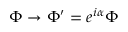Convert formula to latex. <formula><loc_0><loc_0><loc_500><loc_500>\Phi \rightarrow \Phi ^ { \prime } = e ^ { i \alpha } \Phi</formula> 